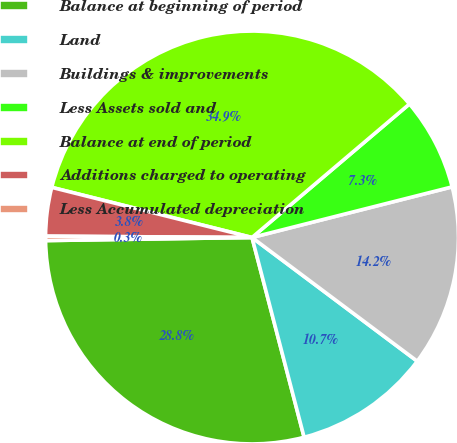Convert chart. <chart><loc_0><loc_0><loc_500><loc_500><pie_chart><fcel>Balance at beginning of period<fcel>Land<fcel>Buildings & improvements<fcel>Less Assets sold and<fcel>Balance at end of period<fcel>Additions charged to operating<fcel>Less Accumulated depreciation<nl><fcel>28.82%<fcel>10.71%<fcel>14.17%<fcel>7.25%<fcel>34.9%<fcel>3.8%<fcel>0.34%<nl></chart> 